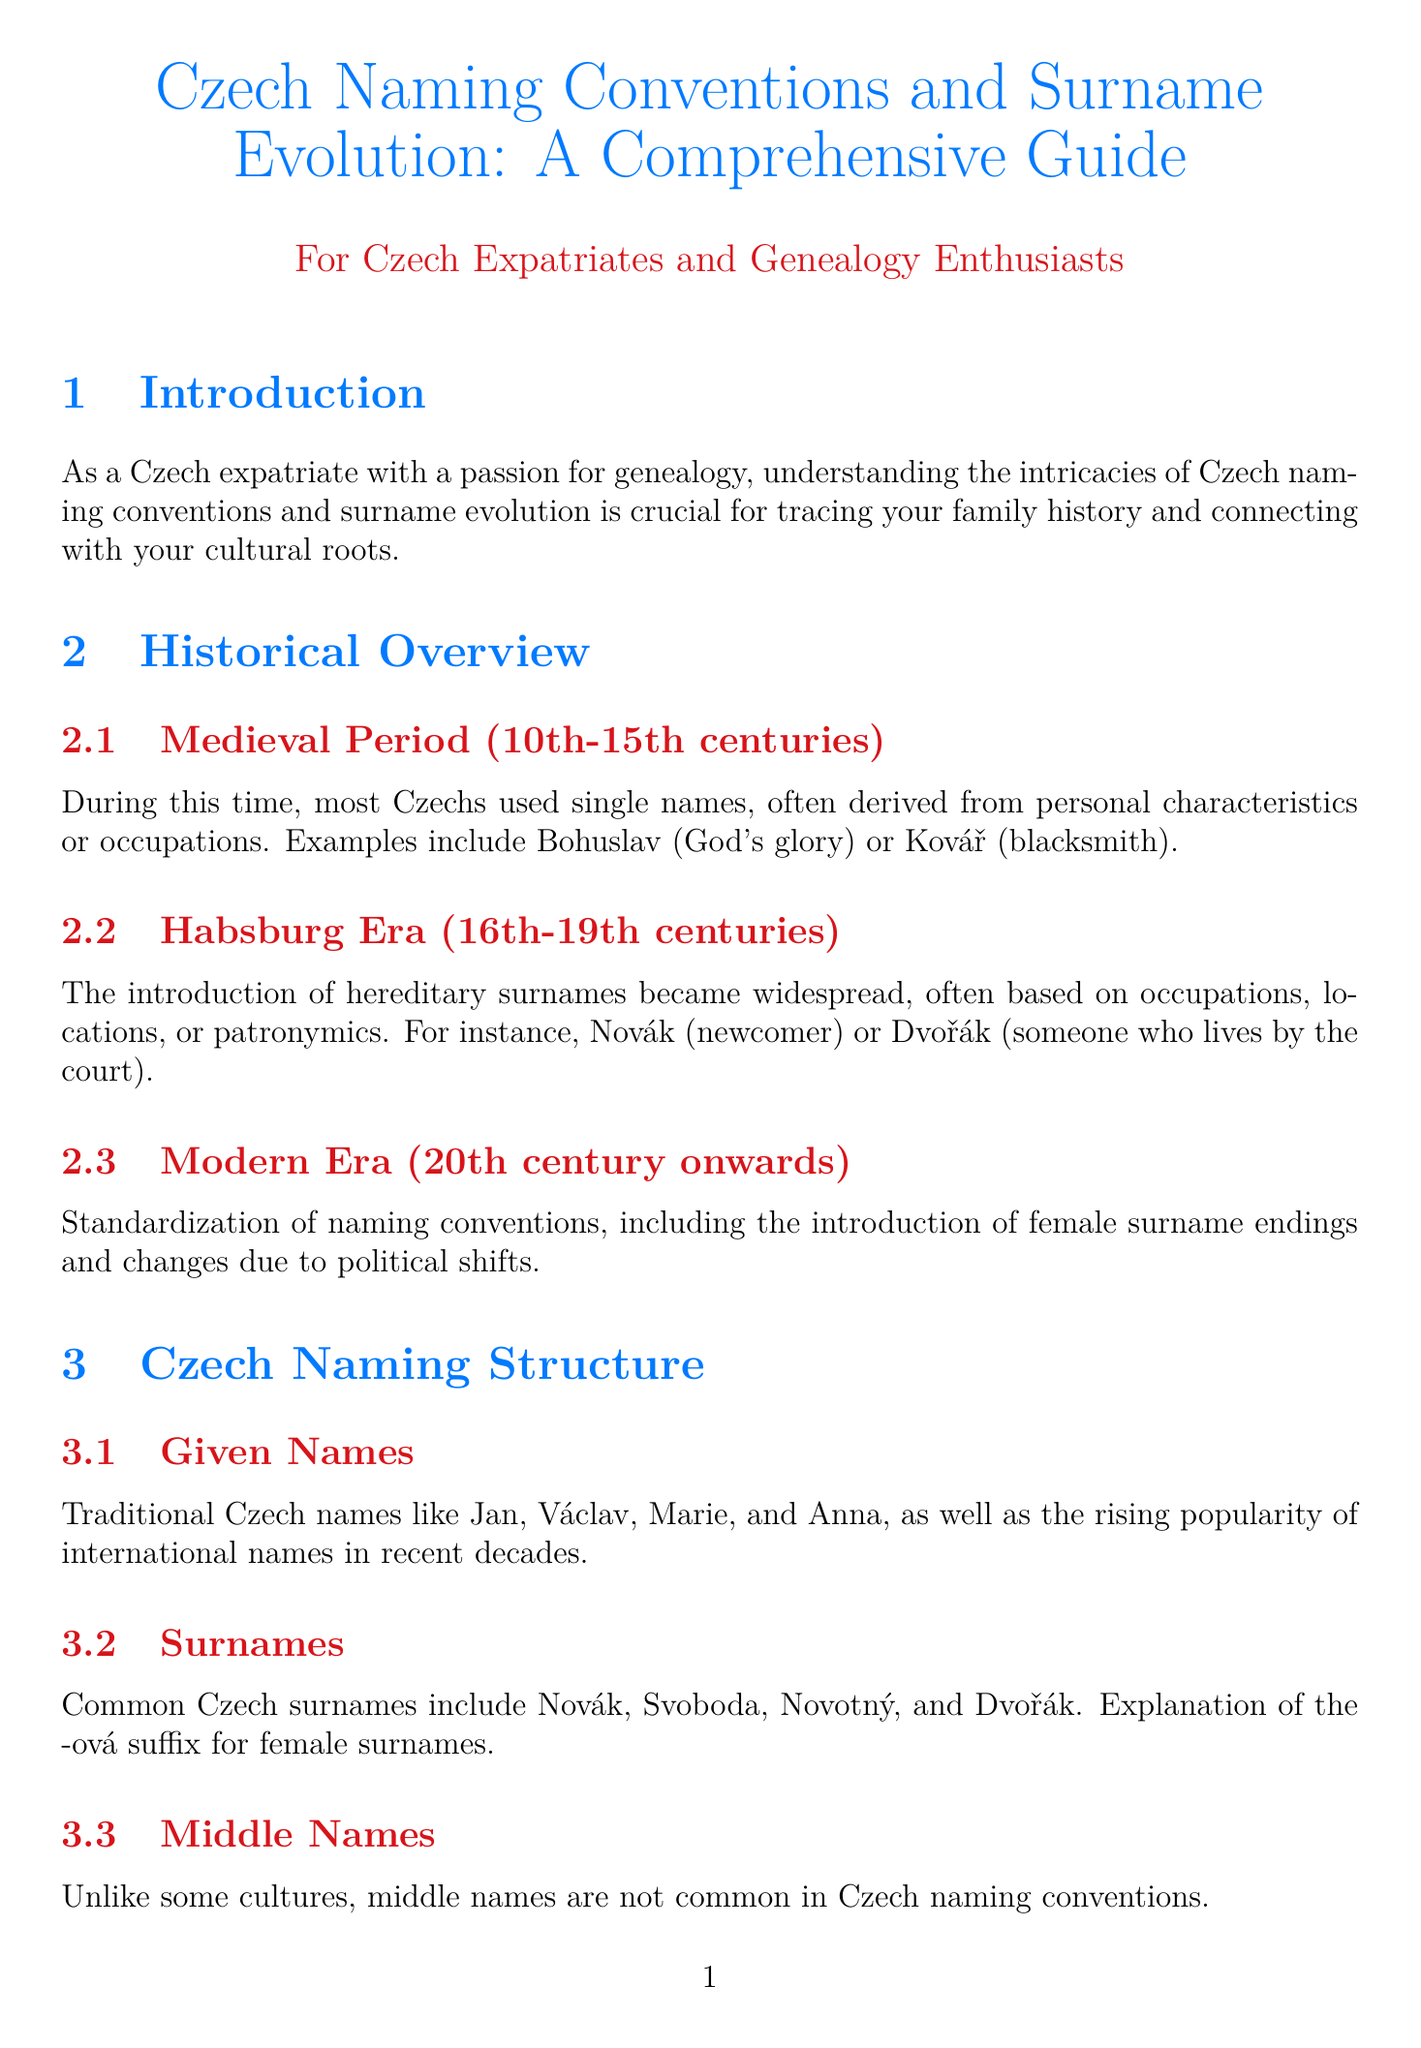what is the title of the guide? The title of the guide is prominently displayed at the beginning of the document.
Answer: Czech Naming Conventions and Surname Evolution: A Comprehensive Guide which period does the Medieval section cover? The Medieval Period section specifies the range of centuries it addresses.
Answer: 10th-15th centuries what suffix is used for female surnames in Czech? The Surnames subsection explains the ending used for female surnames.
Answer: -ová what is an example of a patronymic surname? The document lists examples of patronymic surnames in the relevant subsection.
Answer: Pavlík which family reverted their surname after 1918? The Name Changes and Adaptations section provides a specific example of a family that changed back their surname.
Answer: Černý what is one resource listed for genealogical research? The Genealogical Research Tips section includes various resources for family history research.
Answer: Národní archiv how many case studies are mentioned under Surname Evolution? The Surname Evolution section specifies the number of case studies provided.
Answer: 3 what unique aspect defines Moravian surnames? The Regional Variations section states a specific feature about naming conventions in Moravia.
Answer: ending in -ský 